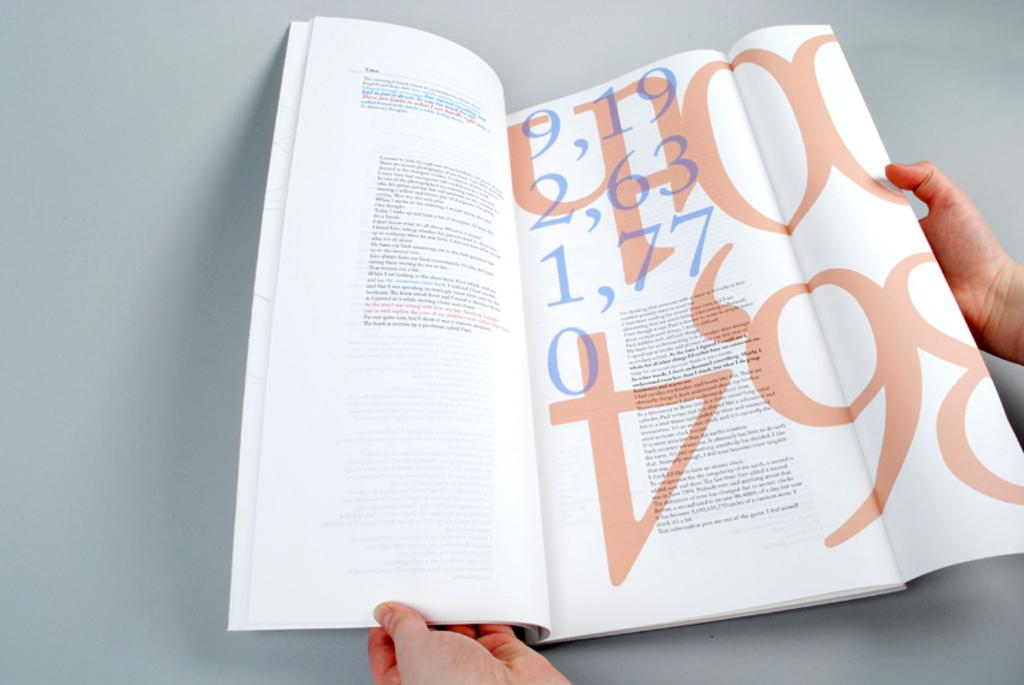<image>
Write a terse but informative summary of the picture. A person has opened a book with the numbers 9, 19, 2, 63, 1, 77, and 0. 